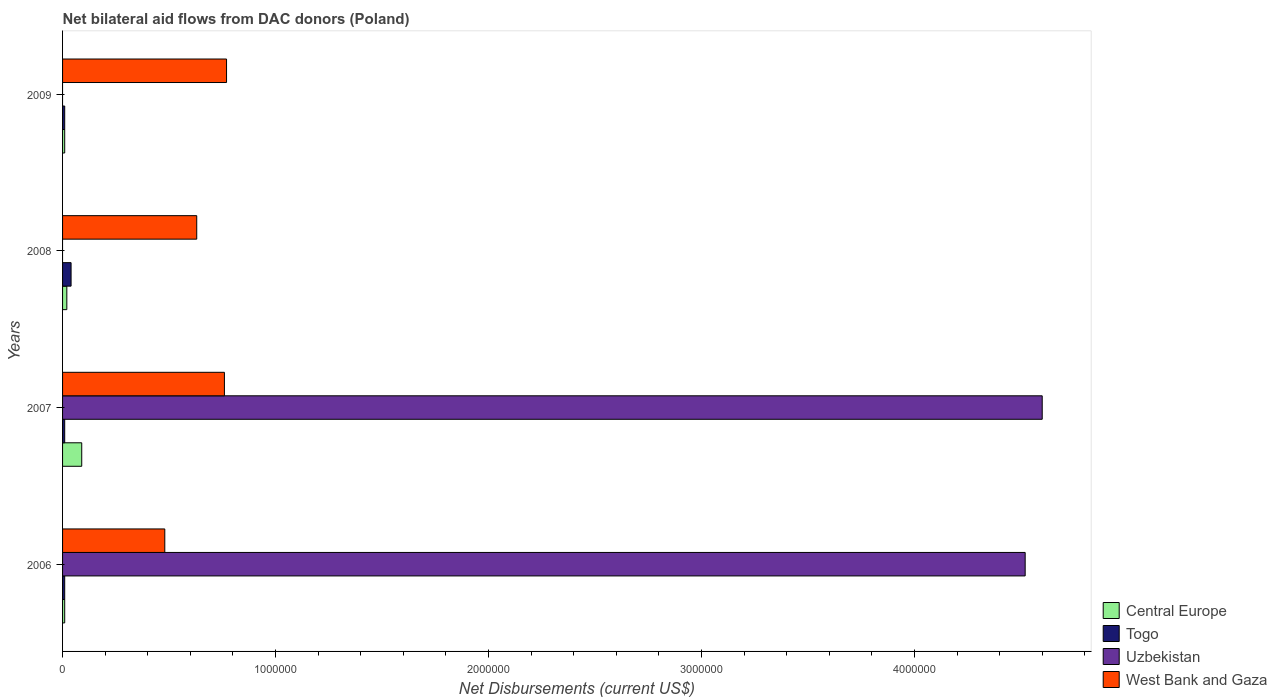How many different coloured bars are there?
Make the answer very short. 4. Are the number of bars per tick equal to the number of legend labels?
Ensure brevity in your answer.  No. How many bars are there on the 3rd tick from the top?
Give a very brief answer. 4. How many bars are there on the 2nd tick from the bottom?
Keep it short and to the point. 4. What is the label of the 3rd group of bars from the top?
Your answer should be compact. 2007. In how many cases, is the number of bars for a given year not equal to the number of legend labels?
Ensure brevity in your answer.  2. What is the net bilateral aid flows in Uzbekistan in 2006?
Offer a terse response. 4.52e+06. Across all years, what is the maximum net bilateral aid flows in Central Europe?
Provide a short and direct response. 9.00e+04. Across all years, what is the minimum net bilateral aid flows in Uzbekistan?
Ensure brevity in your answer.  0. What is the total net bilateral aid flows in Central Europe in the graph?
Offer a terse response. 1.30e+05. What is the difference between the net bilateral aid flows in West Bank and Gaza in 2008 and the net bilateral aid flows in Central Europe in 2007?
Your response must be concise. 5.40e+05. What is the average net bilateral aid flows in Togo per year?
Your answer should be very brief. 1.75e+04. Is the difference between the net bilateral aid flows in Togo in 2007 and 2008 greater than the difference between the net bilateral aid flows in Central Europe in 2007 and 2008?
Provide a succinct answer. No. What is the difference between the highest and the second highest net bilateral aid flows in West Bank and Gaza?
Make the answer very short. 10000. What is the difference between the highest and the lowest net bilateral aid flows in Togo?
Keep it short and to the point. 3.00e+04. Is it the case that in every year, the sum of the net bilateral aid flows in Togo and net bilateral aid flows in Uzbekistan is greater than the net bilateral aid flows in West Bank and Gaza?
Your answer should be very brief. No. How many bars are there?
Provide a short and direct response. 14. What is the difference between two consecutive major ticks on the X-axis?
Provide a succinct answer. 1.00e+06. Does the graph contain grids?
Keep it short and to the point. No. What is the title of the graph?
Give a very brief answer. Net bilateral aid flows from DAC donors (Poland). Does "Liechtenstein" appear as one of the legend labels in the graph?
Ensure brevity in your answer.  No. What is the label or title of the X-axis?
Your answer should be very brief. Net Disbursements (current US$). What is the label or title of the Y-axis?
Your answer should be compact. Years. What is the Net Disbursements (current US$) of Central Europe in 2006?
Ensure brevity in your answer.  10000. What is the Net Disbursements (current US$) in Uzbekistan in 2006?
Make the answer very short. 4.52e+06. What is the Net Disbursements (current US$) in Togo in 2007?
Ensure brevity in your answer.  10000. What is the Net Disbursements (current US$) in Uzbekistan in 2007?
Give a very brief answer. 4.60e+06. What is the Net Disbursements (current US$) in West Bank and Gaza in 2007?
Offer a very short reply. 7.60e+05. What is the Net Disbursements (current US$) in Togo in 2008?
Offer a terse response. 4.00e+04. What is the Net Disbursements (current US$) of Uzbekistan in 2008?
Keep it short and to the point. 0. What is the Net Disbursements (current US$) in West Bank and Gaza in 2008?
Give a very brief answer. 6.30e+05. What is the Net Disbursements (current US$) in Central Europe in 2009?
Your response must be concise. 10000. What is the Net Disbursements (current US$) of West Bank and Gaza in 2009?
Your answer should be compact. 7.70e+05. Across all years, what is the maximum Net Disbursements (current US$) of Uzbekistan?
Offer a terse response. 4.60e+06. Across all years, what is the maximum Net Disbursements (current US$) of West Bank and Gaza?
Make the answer very short. 7.70e+05. Across all years, what is the minimum Net Disbursements (current US$) of Central Europe?
Offer a terse response. 10000. Across all years, what is the minimum Net Disbursements (current US$) in West Bank and Gaza?
Give a very brief answer. 4.80e+05. What is the total Net Disbursements (current US$) in Togo in the graph?
Give a very brief answer. 7.00e+04. What is the total Net Disbursements (current US$) of Uzbekistan in the graph?
Make the answer very short. 9.12e+06. What is the total Net Disbursements (current US$) in West Bank and Gaza in the graph?
Offer a terse response. 2.64e+06. What is the difference between the Net Disbursements (current US$) of Togo in 2006 and that in 2007?
Offer a very short reply. 0. What is the difference between the Net Disbursements (current US$) of Uzbekistan in 2006 and that in 2007?
Provide a short and direct response. -8.00e+04. What is the difference between the Net Disbursements (current US$) of West Bank and Gaza in 2006 and that in 2007?
Keep it short and to the point. -2.80e+05. What is the difference between the Net Disbursements (current US$) of Central Europe in 2006 and that in 2009?
Provide a short and direct response. 0. What is the difference between the Net Disbursements (current US$) in West Bank and Gaza in 2006 and that in 2009?
Give a very brief answer. -2.90e+05. What is the difference between the Net Disbursements (current US$) of Central Europe in 2007 and that in 2008?
Provide a short and direct response. 7.00e+04. What is the difference between the Net Disbursements (current US$) in Togo in 2007 and that in 2008?
Give a very brief answer. -3.00e+04. What is the difference between the Net Disbursements (current US$) in West Bank and Gaza in 2007 and that in 2008?
Keep it short and to the point. 1.30e+05. What is the difference between the Net Disbursements (current US$) of Central Europe in 2007 and that in 2009?
Your answer should be very brief. 8.00e+04. What is the difference between the Net Disbursements (current US$) in West Bank and Gaza in 2007 and that in 2009?
Keep it short and to the point. -10000. What is the difference between the Net Disbursements (current US$) of Central Europe in 2008 and that in 2009?
Your response must be concise. 10000. What is the difference between the Net Disbursements (current US$) of West Bank and Gaza in 2008 and that in 2009?
Make the answer very short. -1.40e+05. What is the difference between the Net Disbursements (current US$) in Central Europe in 2006 and the Net Disbursements (current US$) in Togo in 2007?
Your answer should be compact. 0. What is the difference between the Net Disbursements (current US$) of Central Europe in 2006 and the Net Disbursements (current US$) of Uzbekistan in 2007?
Offer a very short reply. -4.59e+06. What is the difference between the Net Disbursements (current US$) of Central Europe in 2006 and the Net Disbursements (current US$) of West Bank and Gaza in 2007?
Your answer should be very brief. -7.50e+05. What is the difference between the Net Disbursements (current US$) of Togo in 2006 and the Net Disbursements (current US$) of Uzbekistan in 2007?
Provide a short and direct response. -4.59e+06. What is the difference between the Net Disbursements (current US$) of Togo in 2006 and the Net Disbursements (current US$) of West Bank and Gaza in 2007?
Provide a succinct answer. -7.50e+05. What is the difference between the Net Disbursements (current US$) in Uzbekistan in 2006 and the Net Disbursements (current US$) in West Bank and Gaza in 2007?
Give a very brief answer. 3.76e+06. What is the difference between the Net Disbursements (current US$) of Central Europe in 2006 and the Net Disbursements (current US$) of Togo in 2008?
Your answer should be compact. -3.00e+04. What is the difference between the Net Disbursements (current US$) of Central Europe in 2006 and the Net Disbursements (current US$) of West Bank and Gaza in 2008?
Give a very brief answer. -6.20e+05. What is the difference between the Net Disbursements (current US$) in Togo in 2006 and the Net Disbursements (current US$) in West Bank and Gaza in 2008?
Keep it short and to the point. -6.20e+05. What is the difference between the Net Disbursements (current US$) of Uzbekistan in 2006 and the Net Disbursements (current US$) of West Bank and Gaza in 2008?
Your response must be concise. 3.89e+06. What is the difference between the Net Disbursements (current US$) of Central Europe in 2006 and the Net Disbursements (current US$) of Togo in 2009?
Give a very brief answer. 0. What is the difference between the Net Disbursements (current US$) in Central Europe in 2006 and the Net Disbursements (current US$) in West Bank and Gaza in 2009?
Make the answer very short. -7.60e+05. What is the difference between the Net Disbursements (current US$) of Togo in 2006 and the Net Disbursements (current US$) of West Bank and Gaza in 2009?
Make the answer very short. -7.60e+05. What is the difference between the Net Disbursements (current US$) of Uzbekistan in 2006 and the Net Disbursements (current US$) of West Bank and Gaza in 2009?
Your response must be concise. 3.75e+06. What is the difference between the Net Disbursements (current US$) in Central Europe in 2007 and the Net Disbursements (current US$) in Togo in 2008?
Make the answer very short. 5.00e+04. What is the difference between the Net Disbursements (current US$) in Central Europe in 2007 and the Net Disbursements (current US$) in West Bank and Gaza in 2008?
Your answer should be very brief. -5.40e+05. What is the difference between the Net Disbursements (current US$) of Togo in 2007 and the Net Disbursements (current US$) of West Bank and Gaza in 2008?
Offer a terse response. -6.20e+05. What is the difference between the Net Disbursements (current US$) in Uzbekistan in 2007 and the Net Disbursements (current US$) in West Bank and Gaza in 2008?
Your answer should be compact. 3.97e+06. What is the difference between the Net Disbursements (current US$) of Central Europe in 2007 and the Net Disbursements (current US$) of West Bank and Gaza in 2009?
Your answer should be very brief. -6.80e+05. What is the difference between the Net Disbursements (current US$) of Togo in 2007 and the Net Disbursements (current US$) of West Bank and Gaza in 2009?
Provide a short and direct response. -7.60e+05. What is the difference between the Net Disbursements (current US$) in Uzbekistan in 2007 and the Net Disbursements (current US$) in West Bank and Gaza in 2009?
Offer a terse response. 3.83e+06. What is the difference between the Net Disbursements (current US$) of Central Europe in 2008 and the Net Disbursements (current US$) of Togo in 2009?
Ensure brevity in your answer.  10000. What is the difference between the Net Disbursements (current US$) in Central Europe in 2008 and the Net Disbursements (current US$) in West Bank and Gaza in 2009?
Keep it short and to the point. -7.50e+05. What is the difference between the Net Disbursements (current US$) in Togo in 2008 and the Net Disbursements (current US$) in West Bank and Gaza in 2009?
Make the answer very short. -7.30e+05. What is the average Net Disbursements (current US$) in Central Europe per year?
Your answer should be very brief. 3.25e+04. What is the average Net Disbursements (current US$) of Togo per year?
Your response must be concise. 1.75e+04. What is the average Net Disbursements (current US$) of Uzbekistan per year?
Ensure brevity in your answer.  2.28e+06. In the year 2006, what is the difference between the Net Disbursements (current US$) in Central Europe and Net Disbursements (current US$) in Uzbekistan?
Your answer should be very brief. -4.51e+06. In the year 2006, what is the difference between the Net Disbursements (current US$) of Central Europe and Net Disbursements (current US$) of West Bank and Gaza?
Offer a very short reply. -4.70e+05. In the year 2006, what is the difference between the Net Disbursements (current US$) in Togo and Net Disbursements (current US$) in Uzbekistan?
Ensure brevity in your answer.  -4.51e+06. In the year 2006, what is the difference between the Net Disbursements (current US$) of Togo and Net Disbursements (current US$) of West Bank and Gaza?
Give a very brief answer. -4.70e+05. In the year 2006, what is the difference between the Net Disbursements (current US$) of Uzbekistan and Net Disbursements (current US$) of West Bank and Gaza?
Your answer should be very brief. 4.04e+06. In the year 2007, what is the difference between the Net Disbursements (current US$) in Central Europe and Net Disbursements (current US$) in Uzbekistan?
Provide a succinct answer. -4.51e+06. In the year 2007, what is the difference between the Net Disbursements (current US$) of Central Europe and Net Disbursements (current US$) of West Bank and Gaza?
Give a very brief answer. -6.70e+05. In the year 2007, what is the difference between the Net Disbursements (current US$) in Togo and Net Disbursements (current US$) in Uzbekistan?
Keep it short and to the point. -4.59e+06. In the year 2007, what is the difference between the Net Disbursements (current US$) of Togo and Net Disbursements (current US$) of West Bank and Gaza?
Ensure brevity in your answer.  -7.50e+05. In the year 2007, what is the difference between the Net Disbursements (current US$) of Uzbekistan and Net Disbursements (current US$) of West Bank and Gaza?
Provide a short and direct response. 3.84e+06. In the year 2008, what is the difference between the Net Disbursements (current US$) in Central Europe and Net Disbursements (current US$) in Togo?
Give a very brief answer. -2.00e+04. In the year 2008, what is the difference between the Net Disbursements (current US$) in Central Europe and Net Disbursements (current US$) in West Bank and Gaza?
Your answer should be compact. -6.10e+05. In the year 2008, what is the difference between the Net Disbursements (current US$) of Togo and Net Disbursements (current US$) of West Bank and Gaza?
Your answer should be compact. -5.90e+05. In the year 2009, what is the difference between the Net Disbursements (current US$) in Central Europe and Net Disbursements (current US$) in West Bank and Gaza?
Provide a short and direct response. -7.60e+05. In the year 2009, what is the difference between the Net Disbursements (current US$) in Togo and Net Disbursements (current US$) in West Bank and Gaza?
Offer a very short reply. -7.60e+05. What is the ratio of the Net Disbursements (current US$) of Central Europe in 2006 to that in 2007?
Make the answer very short. 0.11. What is the ratio of the Net Disbursements (current US$) of Togo in 2006 to that in 2007?
Provide a succinct answer. 1. What is the ratio of the Net Disbursements (current US$) of Uzbekistan in 2006 to that in 2007?
Keep it short and to the point. 0.98. What is the ratio of the Net Disbursements (current US$) of West Bank and Gaza in 2006 to that in 2007?
Offer a terse response. 0.63. What is the ratio of the Net Disbursements (current US$) of West Bank and Gaza in 2006 to that in 2008?
Keep it short and to the point. 0.76. What is the ratio of the Net Disbursements (current US$) of West Bank and Gaza in 2006 to that in 2009?
Your answer should be very brief. 0.62. What is the ratio of the Net Disbursements (current US$) in Central Europe in 2007 to that in 2008?
Your response must be concise. 4.5. What is the ratio of the Net Disbursements (current US$) in West Bank and Gaza in 2007 to that in 2008?
Give a very brief answer. 1.21. What is the ratio of the Net Disbursements (current US$) in Central Europe in 2007 to that in 2009?
Make the answer very short. 9. What is the ratio of the Net Disbursements (current US$) in Togo in 2008 to that in 2009?
Keep it short and to the point. 4. What is the ratio of the Net Disbursements (current US$) in West Bank and Gaza in 2008 to that in 2009?
Your answer should be very brief. 0.82. What is the difference between the highest and the lowest Net Disbursements (current US$) of Central Europe?
Keep it short and to the point. 8.00e+04. What is the difference between the highest and the lowest Net Disbursements (current US$) in Uzbekistan?
Make the answer very short. 4.60e+06. What is the difference between the highest and the lowest Net Disbursements (current US$) of West Bank and Gaza?
Ensure brevity in your answer.  2.90e+05. 